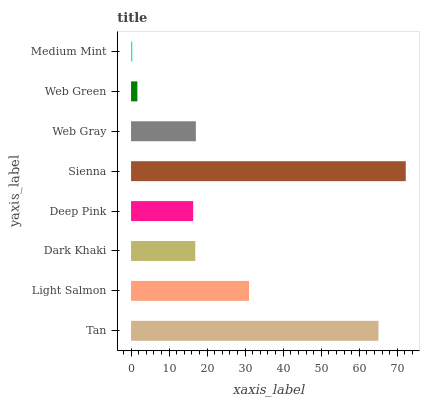Is Medium Mint the minimum?
Answer yes or no. Yes. Is Sienna the maximum?
Answer yes or no. Yes. Is Light Salmon the minimum?
Answer yes or no. No. Is Light Salmon the maximum?
Answer yes or no. No. Is Tan greater than Light Salmon?
Answer yes or no. Yes. Is Light Salmon less than Tan?
Answer yes or no. Yes. Is Light Salmon greater than Tan?
Answer yes or no. No. Is Tan less than Light Salmon?
Answer yes or no. No. Is Web Gray the high median?
Answer yes or no. Yes. Is Dark Khaki the low median?
Answer yes or no. Yes. Is Deep Pink the high median?
Answer yes or no. No. Is Medium Mint the low median?
Answer yes or no. No. 